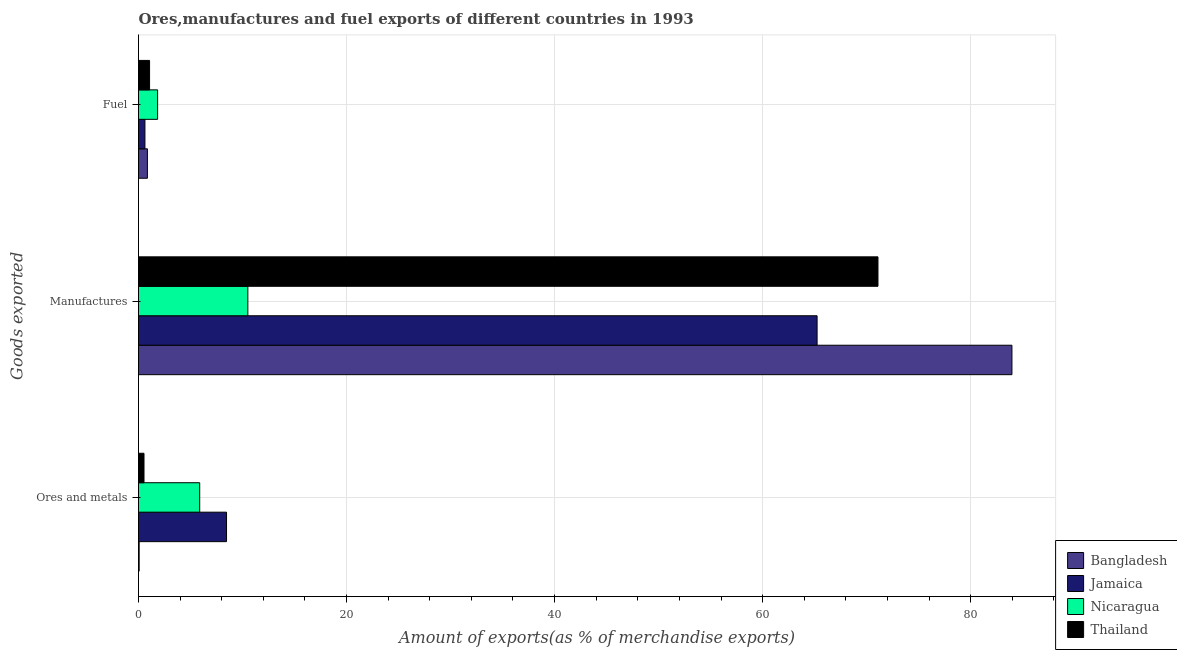How many groups of bars are there?
Provide a succinct answer. 3. Are the number of bars on each tick of the Y-axis equal?
Make the answer very short. Yes. How many bars are there on the 3rd tick from the top?
Your answer should be very brief. 4. What is the label of the 2nd group of bars from the top?
Keep it short and to the point. Manufactures. What is the percentage of manufactures exports in Jamaica?
Your answer should be very brief. 65.24. Across all countries, what is the maximum percentage of ores and metals exports?
Keep it short and to the point. 8.46. Across all countries, what is the minimum percentage of manufactures exports?
Provide a succinct answer. 10.51. In which country was the percentage of ores and metals exports maximum?
Make the answer very short. Jamaica. In which country was the percentage of manufactures exports minimum?
Keep it short and to the point. Nicaragua. What is the total percentage of manufactures exports in the graph?
Your answer should be compact. 230.8. What is the difference between the percentage of manufactures exports in Bangladesh and that in Nicaragua?
Offer a very short reply. 73.46. What is the difference between the percentage of manufactures exports in Bangladesh and the percentage of ores and metals exports in Nicaragua?
Your answer should be compact. 78.08. What is the average percentage of ores and metals exports per country?
Your response must be concise. 3.73. What is the difference between the percentage of ores and metals exports and percentage of fuel exports in Thailand?
Offer a very short reply. -0.54. In how many countries, is the percentage of fuel exports greater than 40 %?
Ensure brevity in your answer.  0. What is the ratio of the percentage of ores and metals exports in Nicaragua to that in Bangladesh?
Provide a short and direct response. 95.42. Is the percentage of fuel exports in Nicaragua less than that in Jamaica?
Your response must be concise. No. What is the difference between the highest and the second highest percentage of ores and metals exports?
Give a very brief answer. 2.58. What is the difference between the highest and the lowest percentage of ores and metals exports?
Ensure brevity in your answer.  8.4. In how many countries, is the percentage of ores and metals exports greater than the average percentage of ores and metals exports taken over all countries?
Your answer should be very brief. 2. What does the 2nd bar from the top in Fuel represents?
Your response must be concise. Nicaragua. What does the 1st bar from the bottom in Fuel represents?
Your answer should be compact. Bangladesh. Is it the case that in every country, the sum of the percentage of ores and metals exports and percentage of manufactures exports is greater than the percentage of fuel exports?
Provide a succinct answer. Yes. Are all the bars in the graph horizontal?
Make the answer very short. Yes. How many countries are there in the graph?
Make the answer very short. 4. What is the difference between two consecutive major ticks on the X-axis?
Provide a short and direct response. 20. Does the graph contain any zero values?
Your answer should be compact. No. Does the graph contain grids?
Your answer should be compact. Yes. What is the title of the graph?
Your response must be concise. Ores,manufactures and fuel exports of different countries in 1993. What is the label or title of the X-axis?
Provide a succinct answer. Amount of exports(as % of merchandise exports). What is the label or title of the Y-axis?
Offer a terse response. Goods exported. What is the Amount of exports(as % of merchandise exports) in Bangladesh in Ores and metals?
Offer a very short reply. 0.06. What is the Amount of exports(as % of merchandise exports) of Jamaica in Ores and metals?
Ensure brevity in your answer.  8.46. What is the Amount of exports(as % of merchandise exports) in Nicaragua in Ores and metals?
Provide a short and direct response. 5.88. What is the Amount of exports(as % of merchandise exports) in Thailand in Ores and metals?
Provide a short and direct response. 0.53. What is the Amount of exports(as % of merchandise exports) of Bangladesh in Manufactures?
Make the answer very short. 83.97. What is the Amount of exports(as % of merchandise exports) of Jamaica in Manufactures?
Your answer should be very brief. 65.24. What is the Amount of exports(as % of merchandise exports) of Nicaragua in Manufactures?
Your response must be concise. 10.51. What is the Amount of exports(as % of merchandise exports) in Thailand in Manufactures?
Give a very brief answer. 71.09. What is the Amount of exports(as % of merchandise exports) of Bangladesh in Fuel?
Offer a very short reply. 0.86. What is the Amount of exports(as % of merchandise exports) of Jamaica in Fuel?
Offer a very short reply. 0.62. What is the Amount of exports(as % of merchandise exports) in Nicaragua in Fuel?
Provide a short and direct response. 1.84. What is the Amount of exports(as % of merchandise exports) in Thailand in Fuel?
Your response must be concise. 1.06. Across all Goods exported, what is the maximum Amount of exports(as % of merchandise exports) in Bangladesh?
Your answer should be compact. 83.97. Across all Goods exported, what is the maximum Amount of exports(as % of merchandise exports) of Jamaica?
Provide a succinct answer. 65.24. Across all Goods exported, what is the maximum Amount of exports(as % of merchandise exports) of Nicaragua?
Keep it short and to the point. 10.51. Across all Goods exported, what is the maximum Amount of exports(as % of merchandise exports) of Thailand?
Make the answer very short. 71.09. Across all Goods exported, what is the minimum Amount of exports(as % of merchandise exports) in Bangladesh?
Keep it short and to the point. 0.06. Across all Goods exported, what is the minimum Amount of exports(as % of merchandise exports) in Jamaica?
Provide a succinct answer. 0.62. Across all Goods exported, what is the minimum Amount of exports(as % of merchandise exports) in Nicaragua?
Ensure brevity in your answer.  1.84. Across all Goods exported, what is the minimum Amount of exports(as % of merchandise exports) of Thailand?
Your response must be concise. 0.53. What is the total Amount of exports(as % of merchandise exports) in Bangladesh in the graph?
Give a very brief answer. 84.88. What is the total Amount of exports(as % of merchandise exports) in Jamaica in the graph?
Offer a very short reply. 74.32. What is the total Amount of exports(as % of merchandise exports) of Nicaragua in the graph?
Your answer should be very brief. 18.23. What is the total Amount of exports(as % of merchandise exports) in Thailand in the graph?
Give a very brief answer. 72.68. What is the difference between the Amount of exports(as % of merchandise exports) in Bangladesh in Ores and metals and that in Manufactures?
Your response must be concise. -83.91. What is the difference between the Amount of exports(as % of merchandise exports) of Jamaica in Ores and metals and that in Manufactures?
Offer a very short reply. -56.77. What is the difference between the Amount of exports(as % of merchandise exports) of Nicaragua in Ores and metals and that in Manufactures?
Give a very brief answer. -4.63. What is the difference between the Amount of exports(as % of merchandise exports) of Thailand in Ores and metals and that in Manufactures?
Make the answer very short. -70.56. What is the difference between the Amount of exports(as % of merchandise exports) of Bangladesh in Ores and metals and that in Fuel?
Make the answer very short. -0.79. What is the difference between the Amount of exports(as % of merchandise exports) in Jamaica in Ores and metals and that in Fuel?
Ensure brevity in your answer.  7.84. What is the difference between the Amount of exports(as % of merchandise exports) in Nicaragua in Ores and metals and that in Fuel?
Offer a terse response. 4.05. What is the difference between the Amount of exports(as % of merchandise exports) of Thailand in Ores and metals and that in Fuel?
Provide a short and direct response. -0.54. What is the difference between the Amount of exports(as % of merchandise exports) in Bangladesh in Manufactures and that in Fuel?
Ensure brevity in your answer.  83.11. What is the difference between the Amount of exports(as % of merchandise exports) in Jamaica in Manufactures and that in Fuel?
Provide a short and direct response. 64.62. What is the difference between the Amount of exports(as % of merchandise exports) of Nicaragua in Manufactures and that in Fuel?
Offer a terse response. 8.67. What is the difference between the Amount of exports(as % of merchandise exports) of Thailand in Manufactures and that in Fuel?
Offer a terse response. 70.02. What is the difference between the Amount of exports(as % of merchandise exports) of Bangladesh in Ores and metals and the Amount of exports(as % of merchandise exports) of Jamaica in Manufactures?
Your answer should be compact. -65.17. What is the difference between the Amount of exports(as % of merchandise exports) of Bangladesh in Ores and metals and the Amount of exports(as % of merchandise exports) of Nicaragua in Manufactures?
Keep it short and to the point. -10.45. What is the difference between the Amount of exports(as % of merchandise exports) of Bangladesh in Ores and metals and the Amount of exports(as % of merchandise exports) of Thailand in Manufactures?
Make the answer very short. -71.03. What is the difference between the Amount of exports(as % of merchandise exports) in Jamaica in Ores and metals and the Amount of exports(as % of merchandise exports) in Nicaragua in Manufactures?
Your response must be concise. -2.05. What is the difference between the Amount of exports(as % of merchandise exports) in Jamaica in Ores and metals and the Amount of exports(as % of merchandise exports) in Thailand in Manufactures?
Your answer should be very brief. -62.63. What is the difference between the Amount of exports(as % of merchandise exports) of Nicaragua in Ores and metals and the Amount of exports(as % of merchandise exports) of Thailand in Manufactures?
Offer a very short reply. -65.2. What is the difference between the Amount of exports(as % of merchandise exports) in Bangladesh in Ores and metals and the Amount of exports(as % of merchandise exports) in Jamaica in Fuel?
Ensure brevity in your answer.  -0.56. What is the difference between the Amount of exports(as % of merchandise exports) in Bangladesh in Ores and metals and the Amount of exports(as % of merchandise exports) in Nicaragua in Fuel?
Your response must be concise. -1.77. What is the difference between the Amount of exports(as % of merchandise exports) of Bangladesh in Ores and metals and the Amount of exports(as % of merchandise exports) of Thailand in Fuel?
Provide a short and direct response. -1. What is the difference between the Amount of exports(as % of merchandise exports) of Jamaica in Ores and metals and the Amount of exports(as % of merchandise exports) of Nicaragua in Fuel?
Give a very brief answer. 6.63. What is the difference between the Amount of exports(as % of merchandise exports) in Jamaica in Ores and metals and the Amount of exports(as % of merchandise exports) in Thailand in Fuel?
Keep it short and to the point. 7.4. What is the difference between the Amount of exports(as % of merchandise exports) in Nicaragua in Ores and metals and the Amount of exports(as % of merchandise exports) in Thailand in Fuel?
Your answer should be very brief. 4.82. What is the difference between the Amount of exports(as % of merchandise exports) in Bangladesh in Manufactures and the Amount of exports(as % of merchandise exports) in Jamaica in Fuel?
Your answer should be very brief. 83.35. What is the difference between the Amount of exports(as % of merchandise exports) of Bangladesh in Manufactures and the Amount of exports(as % of merchandise exports) of Nicaragua in Fuel?
Your answer should be compact. 82.13. What is the difference between the Amount of exports(as % of merchandise exports) of Bangladesh in Manufactures and the Amount of exports(as % of merchandise exports) of Thailand in Fuel?
Provide a short and direct response. 82.9. What is the difference between the Amount of exports(as % of merchandise exports) of Jamaica in Manufactures and the Amount of exports(as % of merchandise exports) of Nicaragua in Fuel?
Keep it short and to the point. 63.4. What is the difference between the Amount of exports(as % of merchandise exports) in Jamaica in Manufactures and the Amount of exports(as % of merchandise exports) in Thailand in Fuel?
Give a very brief answer. 64.17. What is the difference between the Amount of exports(as % of merchandise exports) in Nicaragua in Manufactures and the Amount of exports(as % of merchandise exports) in Thailand in Fuel?
Provide a succinct answer. 9.45. What is the average Amount of exports(as % of merchandise exports) in Bangladesh per Goods exported?
Keep it short and to the point. 28.29. What is the average Amount of exports(as % of merchandise exports) of Jamaica per Goods exported?
Provide a short and direct response. 24.77. What is the average Amount of exports(as % of merchandise exports) of Nicaragua per Goods exported?
Give a very brief answer. 6.08. What is the average Amount of exports(as % of merchandise exports) of Thailand per Goods exported?
Your response must be concise. 24.23. What is the difference between the Amount of exports(as % of merchandise exports) of Bangladesh and Amount of exports(as % of merchandise exports) of Jamaica in Ores and metals?
Your response must be concise. -8.4. What is the difference between the Amount of exports(as % of merchandise exports) of Bangladesh and Amount of exports(as % of merchandise exports) of Nicaragua in Ores and metals?
Your answer should be very brief. -5.82. What is the difference between the Amount of exports(as % of merchandise exports) in Bangladesh and Amount of exports(as % of merchandise exports) in Thailand in Ores and metals?
Offer a terse response. -0.47. What is the difference between the Amount of exports(as % of merchandise exports) in Jamaica and Amount of exports(as % of merchandise exports) in Nicaragua in Ores and metals?
Give a very brief answer. 2.58. What is the difference between the Amount of exports(as % of merchandise exports) in Jamaica and Amount of exports(as % of merchandise exports) in Thailand in Ores and metals?
Make the answer very short. 7.93. What is the difference between the Amount of exports(as % of merchandise exports) in Nicaragua and Amount of exports(as % of merchandise exports) in Thailand in Ores and metals?
Provide a short and direct response. 5.36. What is the difference between the Amount of exports(as % of merchandise exports) of Bangladesh and Amount of exports(as % of merchandise exports) of Jamaica in Manufactures?
Give a very brief answer. 18.73. What is the difference between the Amount of exports(as % of merchandise exports) in Bangladesh and Amount of exports(as % of merchandise exports) in Nicaragua in Manufactures?
Provide a short and direct response. 73.46. What is the difference between the Amount of exports(as % of merchandise exports) of Bangladesh and Amount of exports(as % of merchandise exports) of Thailand in Manufactures?
Ensure brevity in your answer.  12.88. What is the difference between the Amount of exports(as % of merchandise exports) of Jamaica and Amount of exports(as % of merchandise exports) of Nicaragua in Manufactures?
Make the answer very short. 54.73. What is the difference between the Amount of exports(as % of merchandise exports) in Jamaica and Amount of exports(as % of merchandise exports) in Thailand in Manufactures?
Keep it short and to the point. -5.85. What is the difference between the Amount of exports(as % of merchandise exports) of Nicaragua and Amount of exports(as % of merchandise exports) of Thailand in Manufactures?
Your answer should be compact. -60.58. What is the difference between the Amount of exports(as % of merchandise exports) of Bangladesh and Amount of exports(as % of merchandise exports) of Jamaica in Fuel?
Provide a succinct answer. 0.24. What is the difference between the Amount of exports(as % of merchandise exports) in Bangladesh and Amount of exports(as % of merchandise exports) in Nicaragua in Fuel?
Your answer should be very brief. -0.98. What is the difference between the Amount of exports(as % of merchandise exports) in Bangladesh and Amount of exports(as % of merchandise exports) in Thailand in Fuel?
Provide a short and direct response. -0.21. What is the difference between the Amount of exports(as % of merchandise exports) in Jamaica and Amount of exports(as % of merchandise exports) in Nicaragua in Fuel?
Your answer should be compact. -1.22. What is the difference between the Amount of exports(as % of merchandise exports) of Jamaica and Amount of exports(as % of merchandise exports) of Thailand in Fuel?
Give a very brief answer. -0.45. What is the difference between the Amount of exports(as % of merchandise exports) of Nicaragua and Amount of exports(as % of merchandise exports) of Thailand in Fuel?
Keep it short and to the point. 0.77. What is the ratio of the Amount of exports(as % of merchandise exports) of Bangladesh in Ores and metals to that in Manufactures?
Give a very brief answer. 0. What is the ratio of the Amount of exports(as % of merchandise exports) in Jamaica in Ores and metals to that in Manufactures?
Provide a succinct answer. 0.13. What is the ratio of the Amount of exports(as % of merchandise exports) of Nicaragua in Ores and metals to that in Manufactures?
Your answer should be compact. 0.56. What is the ratio of the Amount of exports(as % of merchandise exports) of Thailand in Ores and metals to that in Manufactures?
Your response must be concise. 0.01. What is the ratio of the Amount of exports(as % of merchandise exports) of Bangladesh in Ores and metals to that in Fuel?
Ensure brevity in your answer.  0.07. What is the ratio of the Amount of exports(as % of merchandise exports) in Jamaica in Ores and metals to that in Fuel?
Your response must be concise. 13.7. What is the ratio of the Amount of exports(as % of merchandise exports) of Nicaragua in Ores and metals to that in Fuel?
Your answer should be compact. 3.2. What is the ratio of the Amount of exports(as % of merchandise exports) in Thailand in Ores and metals to that in Fuel?
Your answer should be very brief. 0.5. What is the ratio of the Amount of exports(as % of merchandise exports) in Bangladesh in Manufactures to that in Fuel?
Give a very brief answer. 98.18. What is the ratio of the Amount of exports(as % of merchandise exports) in Jamaica in Manufactures to that in Fuel?
Provide a succinct answer. 105.61. What is the ratio of the Amount of exports(as % of merchandise exports) in Nicaragua in Manufactures to that in Fuel?
Ensure brevity in your answer.  5.72. What is the ratio of the Amount of exports(as % of merchandise exports) in Thailand in Manufactures to that in Fuel?
Offer a very short reply. 66.82. What is the difference between the highest and the second highest Amount of exports(as % of merchandise exports) of Bangladesh?
Your answer should be very brief. 83.11. What is the difference between the highest and the second highest Amount of exports(as % of merchandise exports) in Jamaica?
Offer a very short reply. 56.77. What is the difference between the highest and the second highest Amount of exports(as % of merchandise exports) of Nicaragua?
Give a very brief answer. 4.63. What is the difference between the highest and the second highest Amount of exports(as % of merchandise exports) in Thailand?
Give a very brief answer. 70.02. What is the difference between the highest and the lowest Amount of exports(as % of merchandise exports) of Bangladesh?
Make the answer very short. 83.91. What is the difference between the highest and the lowest Amount of exports(as % of merchandise exports) of Jamaica?
Your answer should be very brief. 64.62. What is the difference between the highest and the lowest Amount of exports(as % of merchandise exports) of Nicaragua?
Offer a very short reply. 8.67. What is the difference between the highest and the lowest Amount of exports(as % of merchandise exports) in Thailand?
Ensure brevity in your answer.  70.56. 